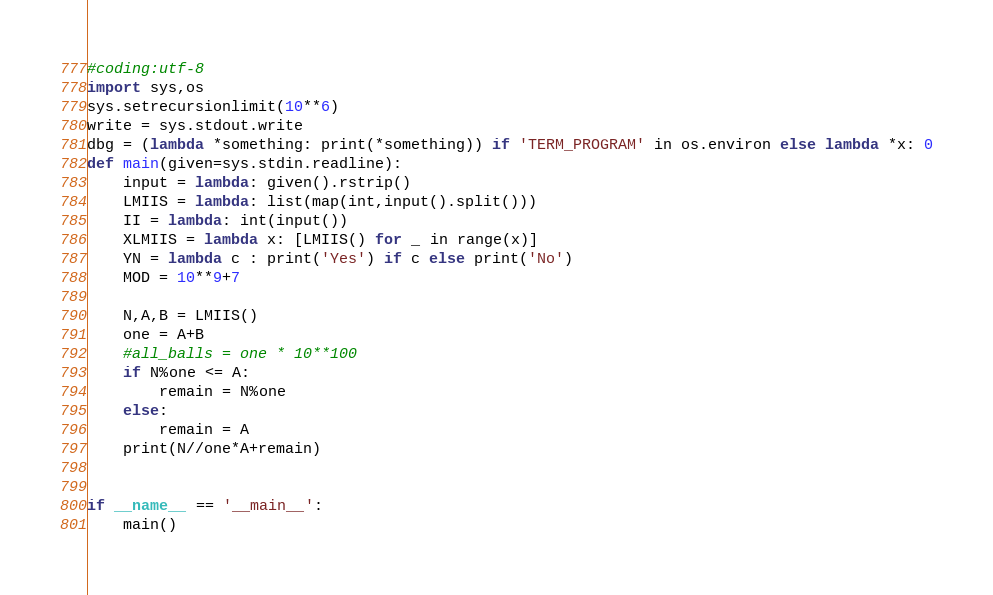<code> <loc_0><loc_0><loc_500><loc_500><_Python_>#coding:utf-8
import sys,os
sys.setrecursionlimit(10**6)
write = sys.stdout.write
dbg = (lambda *something: print(*something)) if 'TERM_PROGRAM' in os.environ else lambda *x: 0
def main(given=sys.stdin.readline):
    input = lambda: given().rstrip()
    LMIIS = lambda: list(map(int,input().split()))
    II = lambda: int(input())
    XLMIIS = lambda x: [LMIIS() for _ in range(x)]
    YN = lambda c : print('Yes') if c else print('No')
    MOD = 10**9+7

    N,A,B = LMIIS()
    one = A+B
    #all_balls = one * 10**100
    if N%one <= A:
        remain = N%one
    else:
        remain = A
    print(N//one*A+remain)


if __name__ == '__main__':
    main()</code> 